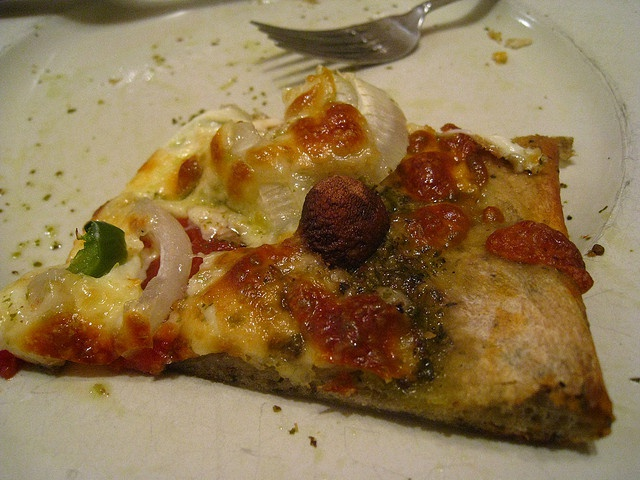Describe the objects in this image and their specific colors. I can see pizza in black, maroon, and olive tones and fork in black and gray tones in this image. 